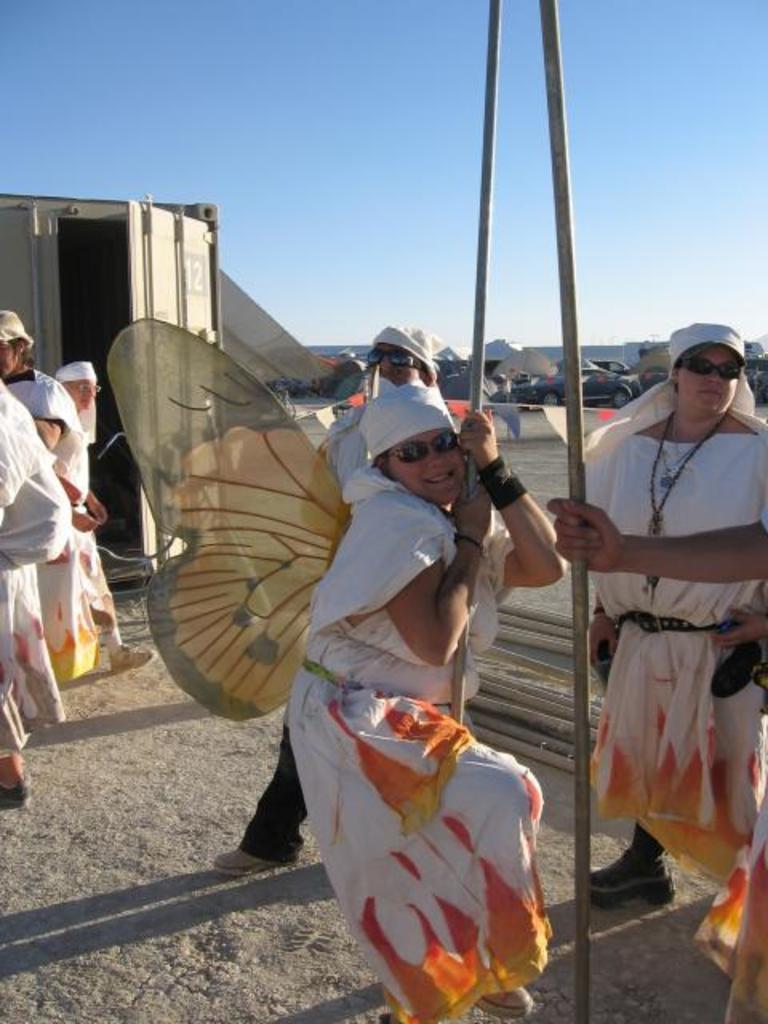Please provide a concise description of this image. In this image, we can see few people are standing on the ground. Here a woman is holding a rod. Few people are wearing different costumes. Background we can see container, few vehicles and sky. On the right side of the image, human hand is holding a rod. 